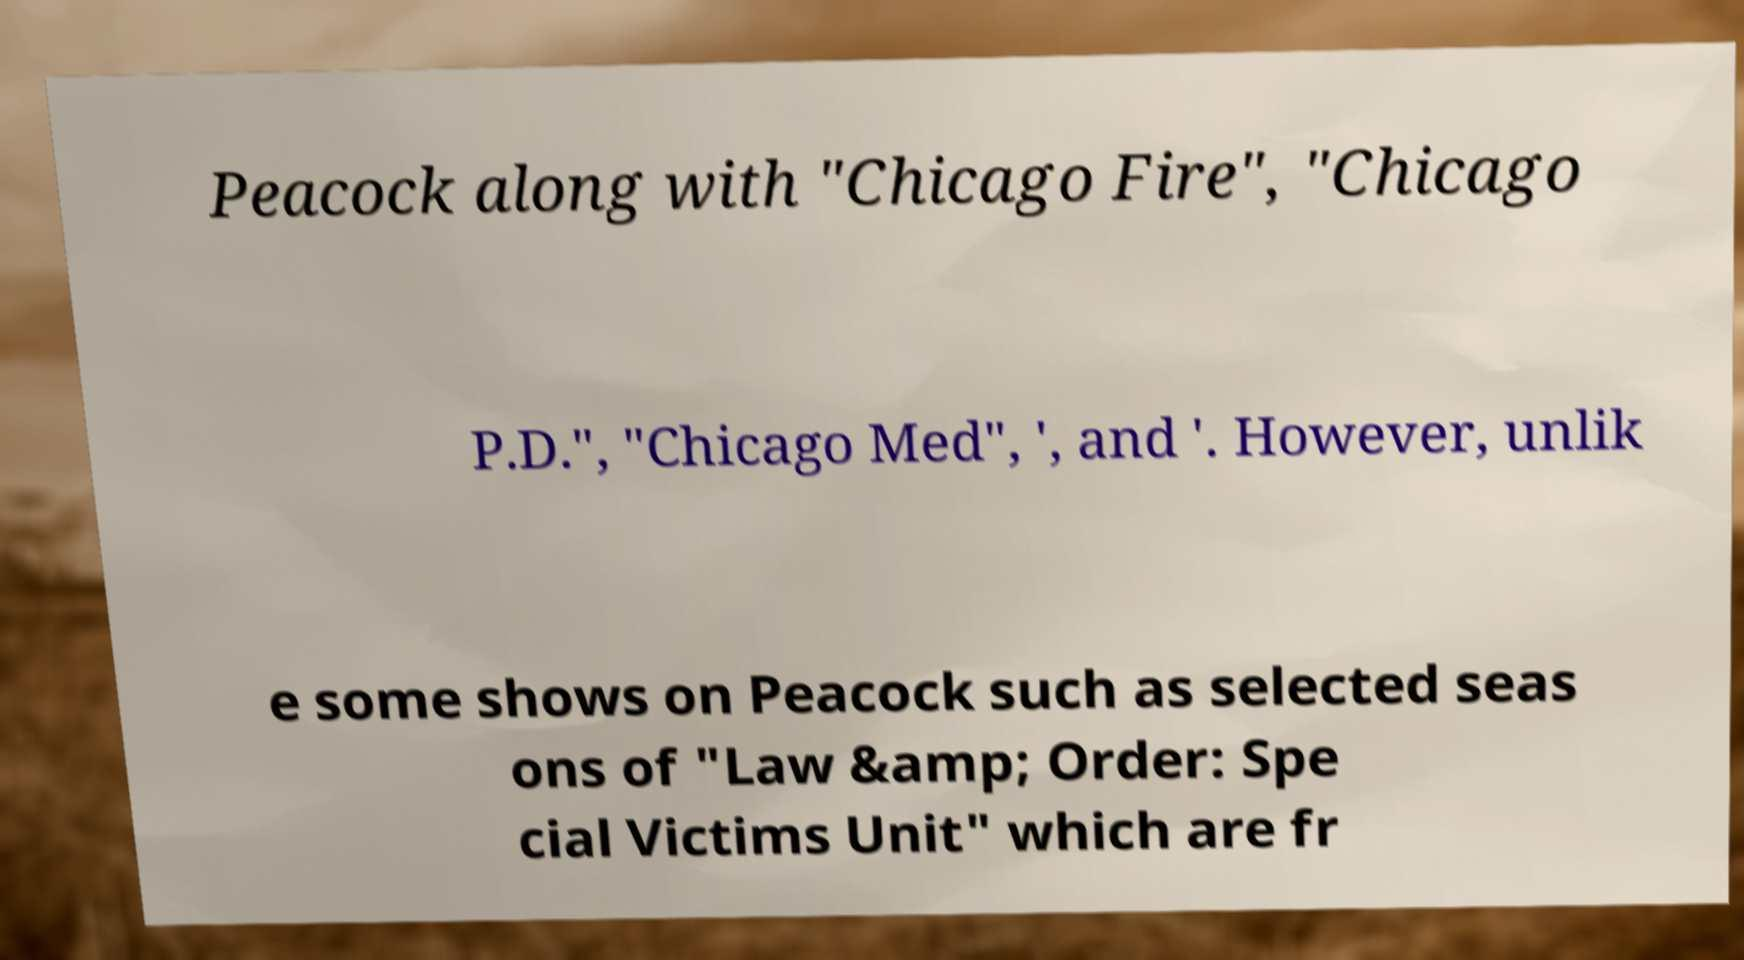Can you accurately transcribe the text from the provided image for me? Peacock along with "Chicago Fire", "Chicago P.D.", "Chicago Med", ', and '. However, unlik e some shows on Peacock such as selected seas ons of "Law &amp; Order: Spe cial Victims Unit" which are fr 